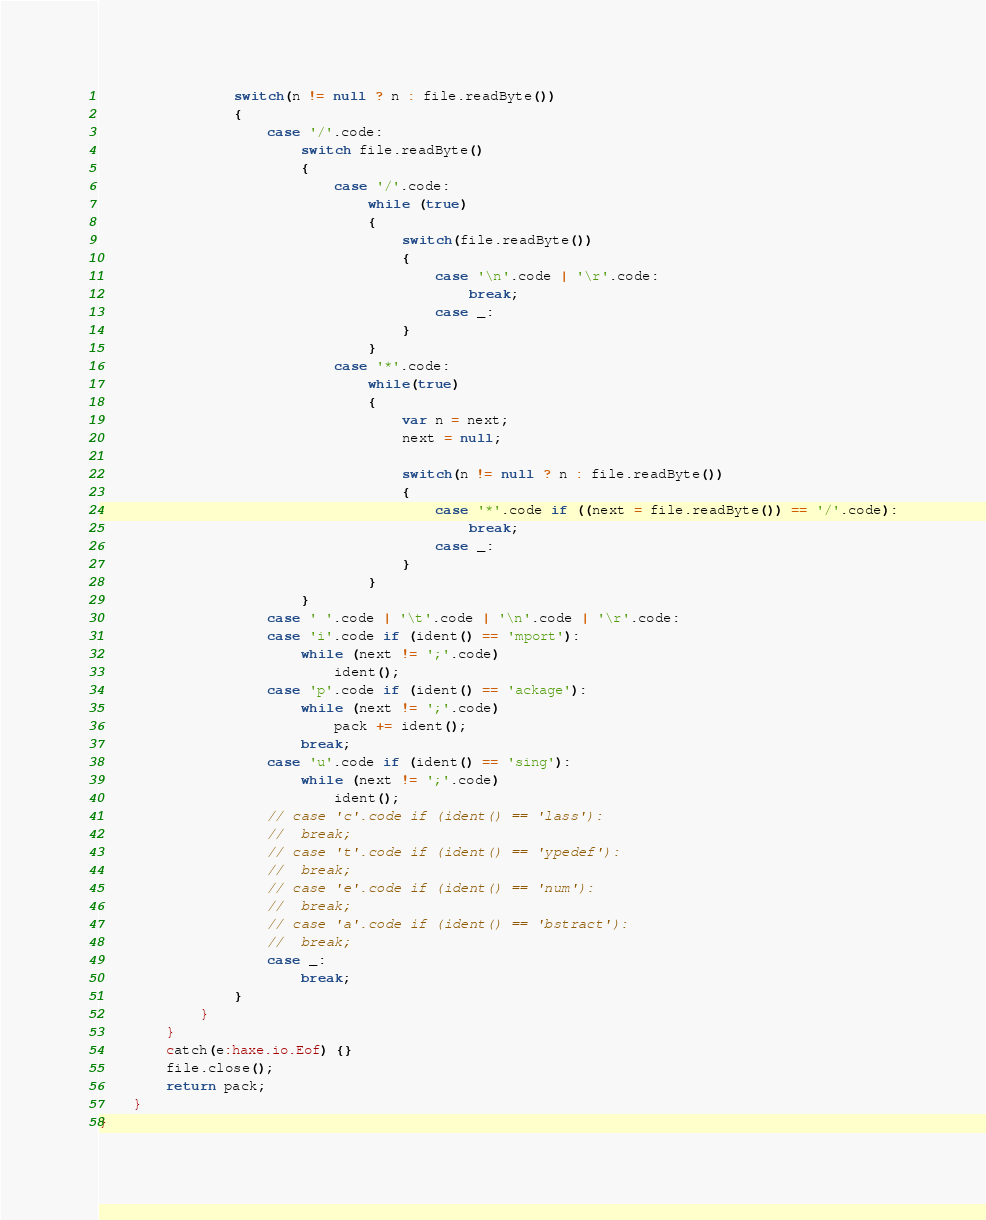<code> <loc_0><loc_0><loc_500><loc_500><_Haxe_>
				switch(n != null ? n : file.readByte())
				{
					case '/'.code:
						switch file.readByte()
						{
							case '/'.code:
								while (true)
								{
									switch(file.readByte())
									{
										case '\n'.code | '\r'.code:
											break;
										case _:
									}
								}
							case '*'.code:
								while(true)
								{
									var n = next;
									next = null;

									switch(n != null ? n : file.readByte())
									{
										case '*'.code if ((next = file.readByte()) == '/'.code):
											break;
										case _:
									}
								}
						}
					case ' '.code | '\t'.code | '\n'.code | '\r'.code:
					case 'i'.code if (ident() == 'mport'):
						while (next != ';'.code)
							ident();
					case 'p'.code if (ident() == 'ackage'):
						while (next != ';'.code)
							pack += ident();
						break;
					case 'u'.code if (ident() == 'sing'):
						while (next != ';'.code)
							ident();
					// case 'c'.code if (ident() == 'lass'):
					// 	break;
					// case 't'.code if (ident() == 'ypedef'):
					// 	break;
					// case 'e'.code if (ident() == 'num'):
					// 	break;
					// case 'a'.code if (ident() == 'bstract'):
					// 	break;
					case _:
						break;
				}
			}
		}
		catch(e:haxe.io.Eof) {}
		file.close();
		return pack;
	}
}
</code> 